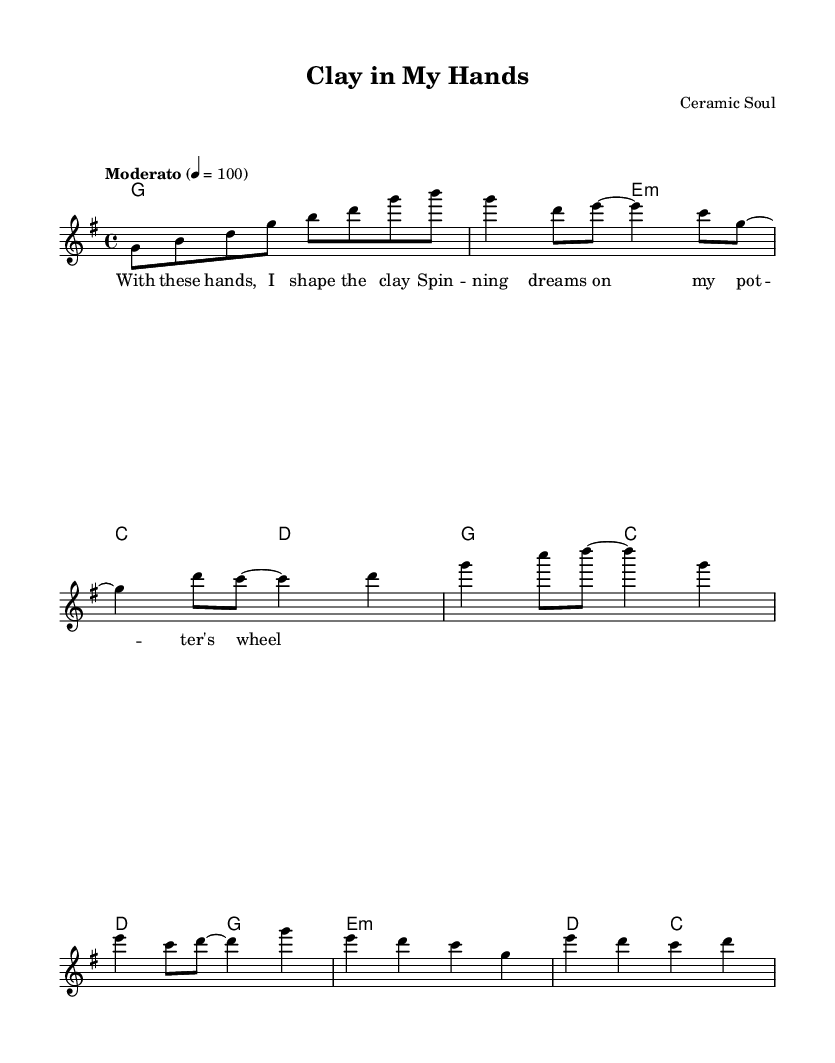What is the key signature of this music? The key signature indicated in the music sheet is G major, which contains one sharp, F#.
Answer: G major What is the time signature of this music? The time signature is represented by the fraction 4/4, which means there are four beats per measure and the quarter note gets one beat.
Answer: 4/4 What is the tempo marking for this piece? The tempo marking is indicated as "Moderato," which typically means a moderate speed. The number 100 indicates the beats per minute.
Answer: Moderato What chord is played in the introduction? The introduction consists of a single chord played over the measure. The chord shown is G.
Answer: G In the chorus, what is the last note in the melody? To find the last note of the chorus, we look at the melody line in the sheet music; it ends on G before moving to the next section.
Answer: G What is the highest note in the melody? By examining the melody line, the highest note reached is B during the intro. This is visually identifiable as the topmost note on the staff.
Answer: B How many different chords are used in the verse section? The verse section includes two different chords: G and E minor, shown in the chord names below the staff.
Answer: 2 